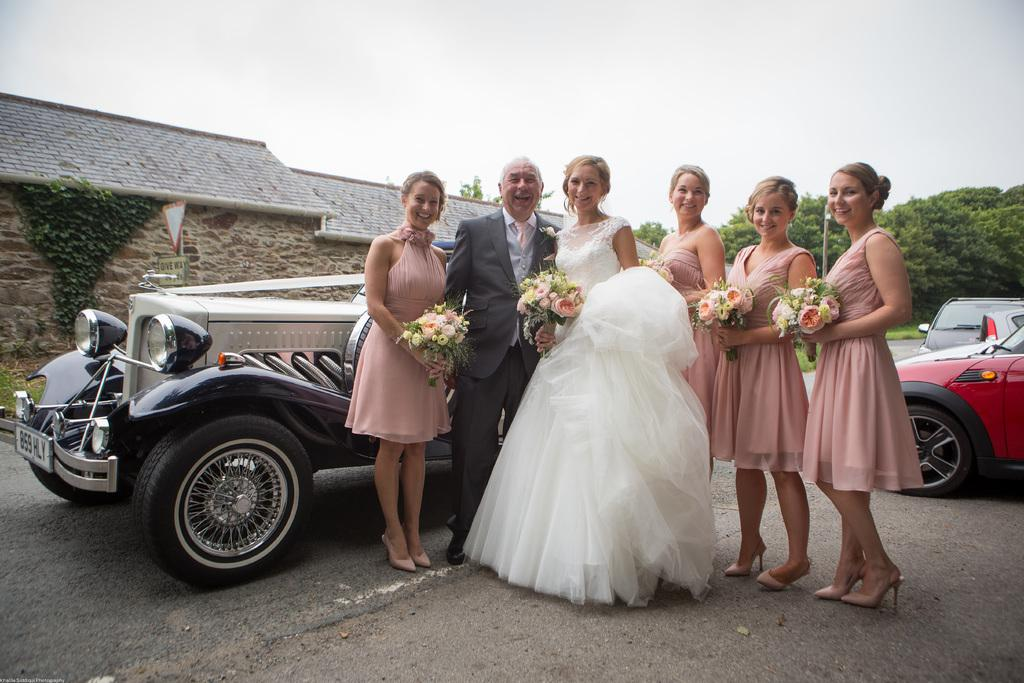What are the persons in the image holding? The persons in the image are holding bouquets. Where are the persons standing in the image? They are standing on the road. What can be seen in the background of the image? There are cars, buildings, a wall, grass, trees, and the sky visible in the background of the image. What type of club is being used by the persons in the image? There is no club visible in the image; the persons are holding bouquets. In which direction are the persons in the image facing? The direction the persons are facing cannot be determined from the image. 